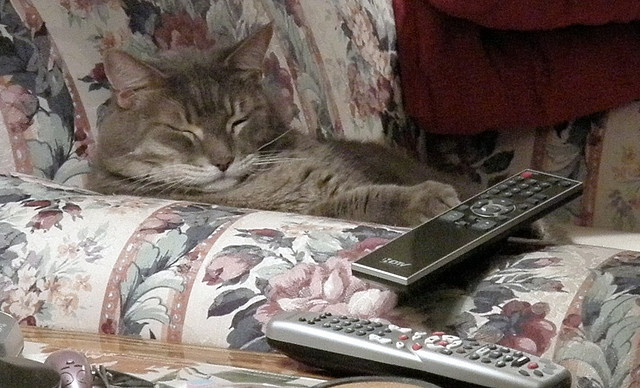Describe the objects in this image and their specific colors. I can see couch in gray, darkgray, black, and lightgray tones, cat in gray and black tones, remote in gray, darkgray, white, and black tones, and remote in gray, black, and darkgray tones in this image. 